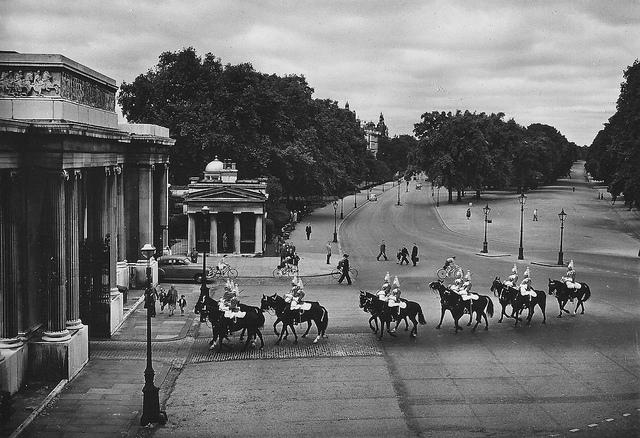What kind of building is it on the left? Please explain your reasoning. government building. The building is for the government. 